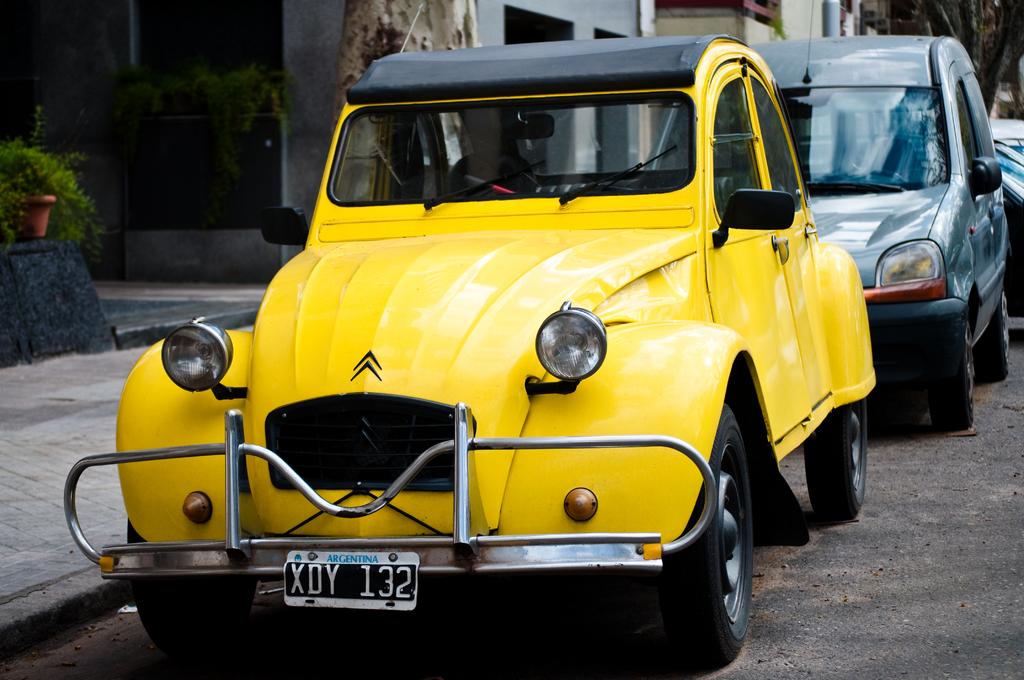What is the license plate number?
Make the answer very short. Xdy 132. What is the license plate number?
Offer a terse response. Xdy 132. 